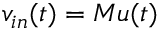Convert formula to latex. <formula><loc_0><loc_0><loc_500><loc_500>v _ { i n } ( t ) = M u ( t )</formula> 